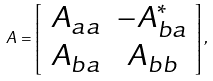Convert formula to latex. <formula><loc_0><loc_0><loc_500><loc_500>A = \left [ \begin{array} { c c } A _ { a a } & - A _ { b a } ^ { * } \\ A _ { b a } & A _ { b b } \end{array} \right ] ,</formula> 